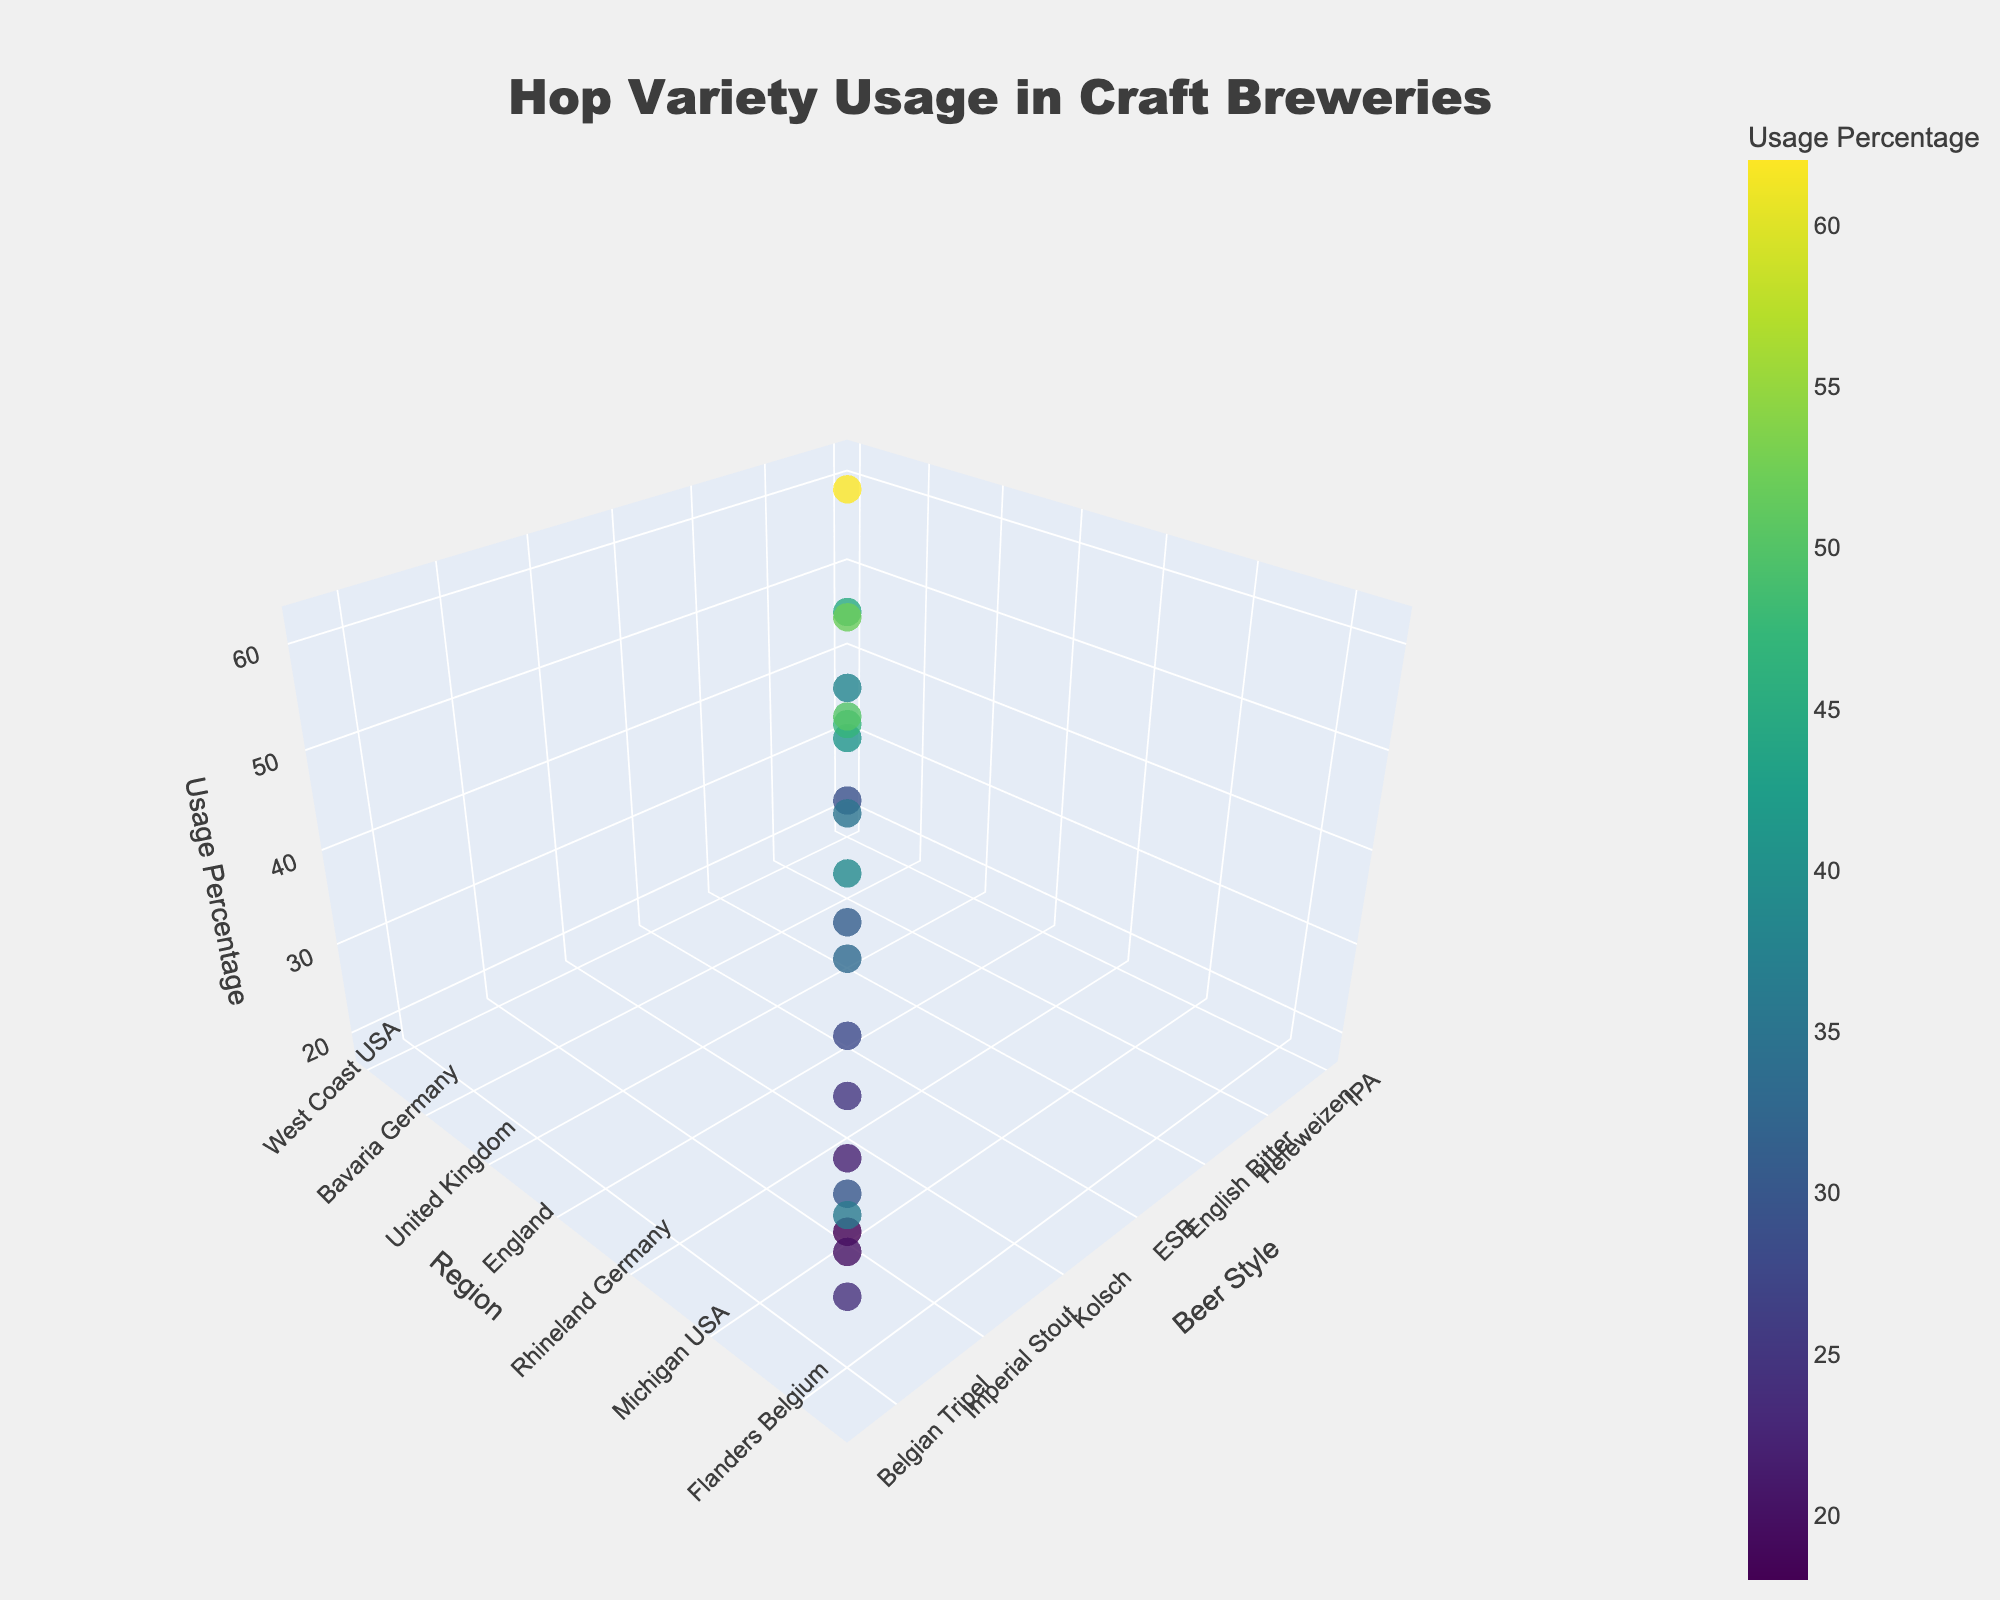How many data points are there in the plot? There are 18 entries in the data provided, and each entry corresponds to a single data point in the plot.
Answer: 18 Which beer style from Bavaria, Germany, uses Hallertau hops and what's its usage percentage? By hovering over the data points or looking at the axis labels, Hallertau is used for Hefeweizen in Bavaria, Germany with a usage percentage of 29%.
Answer: Hefeweizen, 29% Which hop variety is used the most in the Pacific Northwest, USA? By observing the data points on the plot and the regions, Cascade is used in the Pacific Northwest, USA with a usage percentage of 52%, the highest for this region.
Answer: Cascade Compare the usage percentages of Simcoe and Amarillo hops in their respective regions. Which one is higher and by how much? Simcoe has a usage percentage of 50% in California, USA, while Amarillo has a usage percentage of 47% in Colorado, USA. The difference is 50% - 47% = 3%.
Answer: Simcoe, by 3% What is the average usage percentage of hops in European regions (Flanders Belgium, Rhineland Germany, Czech Republic, Bavaria Germany, United Kingdom, Belgium)? Calculate usage percentages and average them: (24% + 28% + 62% + 29% + 35% + 20%) = 198%. Average is 198% / 6 = 33%.
Answer: 33% Which region has the most diverse beer styles represented in the plot? By counting the unique beer styles associated with each region, the USA has the most diverse representation, encompassing several styles including IPA, Pale Ale, Barleywine, Porter, etc.
Answer: USA Find the beer style with the highest usage percentage and identify the hop variety and region. By identifying the maximum value in the z-axis (Usage Percentage), the highest is for Pilsner in the Czech Republic using Saaz with a usage percentage of 62%.
Answer: Pilsner, Saaz, Czech Republic How does the usage of Citra in West Coast USA compare to the usage of Mosaic in Northeast USA? Hover over the data points or check the axes: Citra is used 45% in West Coast USA, while Mosaic is at 38% in Northeast USA. Citra has a higher usage by 45% - 38% = 7%.
Answer: Citra, by 7% What is the range of usage percentages for beer styles in Germany? Look at the usage percentages for entries with regions Bavaria and Rhineland Germany: Hallertau (29%), Tettnang (28%). The range is 29% - 28% = 1%.
Answer: 1% Which two hop varieties have the closest usage percentages, and what are their beer styles and regions? Observing the plot, Tettnang (Kolsch, Rhineland Germany) has 28% and Hallertau (Hefeweizen, Bavaria Germany) has 29%, with a difference of 1%.
Answer: Tettnang and Hallertau, 1% 